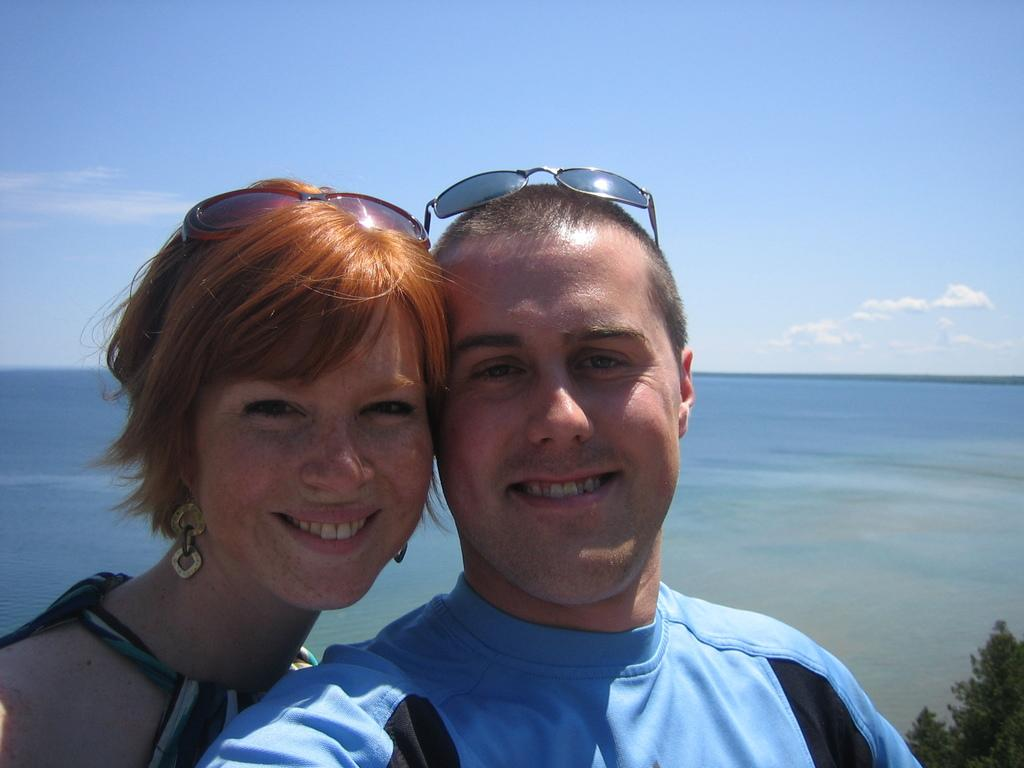How many people are in the image? There are two people in the image, a man and a woman. What are the man and woman doing in the image? The man and woman are standing and smiling. What are the man and woman wearing in the image? The man and woman are wearing sunglasses. What can be seen in the background of the image? There is water, a tree, and a blue and cloudy sky visible in the image. What type of eggnog can be seen in the man's hand in the image? There is no eggnog present in the image; the man and woman are not holding any drinks. What season is depicted in the image, given the presence of a tree and blue sky? The season cannot be definitively determined from the image, as trees and blue skies can be present in various seasons. 